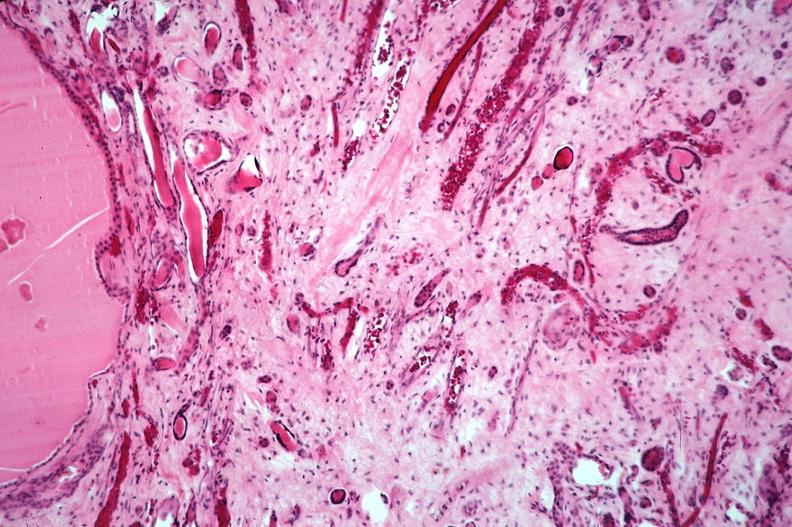what does this image show?
Answer the question using a single word or phrase. Kidney 